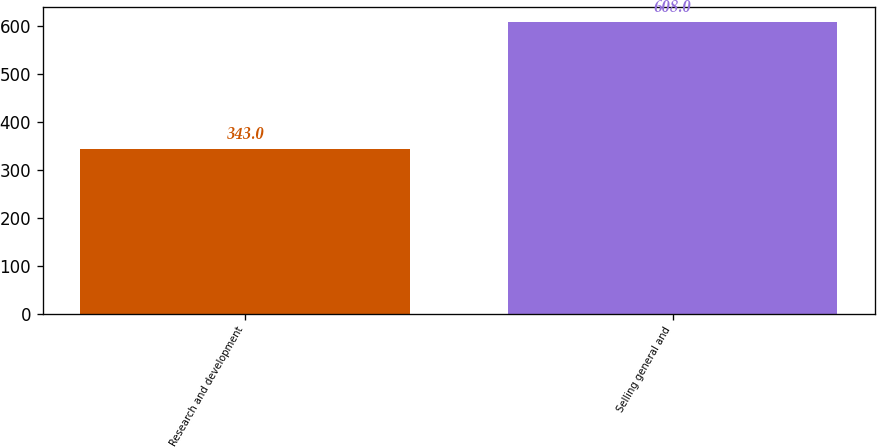<chart> <loc_0><loc_0><loc_500><loc_500><bar_chart><fcel>Research and development<fcel>Selling general and<nl><fcel>343<fcel>608<nl></chart> 